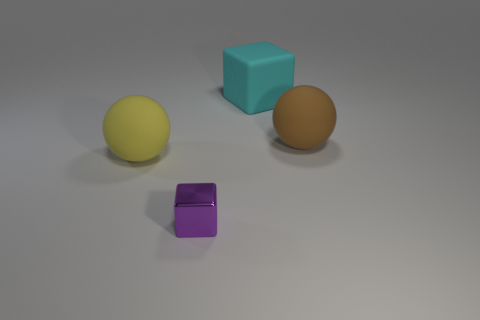How many other things are there of the same material as the small purple cube?
Your response must be concise. 0. The rubber thing that is left of the shiny cube is what color?
Your response must be concise. Yellow. The large ball behind the large ball in front of the large matte sphere that is right of the tiny shiny object is made of what material?
Your answer should be very brief. Rubber. Are there any other big yellow matte things of the same shape as the large yellow matte object?
Provide a short and direct response. No. What shape is the cyan rubber thing that is the same size as the yellow rubber thing?
Offer a terse response. Cube. What number of big matte objects are behind the big brown matte sphere and on the left side of the small purple shiny cube?
Give a very brief answer. 0. Are there fewer brown rubber balls that are to the left of the large yellow object than tiny yellow metal balls?
Your answer should be very brief. No. Is there a purple shiny sphere of the same size as the brown object?
Offer a terse response. No. The big cube that is made of the same material as the large yellow sphere is what color?
Your answer should be very brief. Cyan. There is a big cyan cube that is on the right side of the purple object; how many big matte spheres are right of it?
Make the answer very short. 1. 